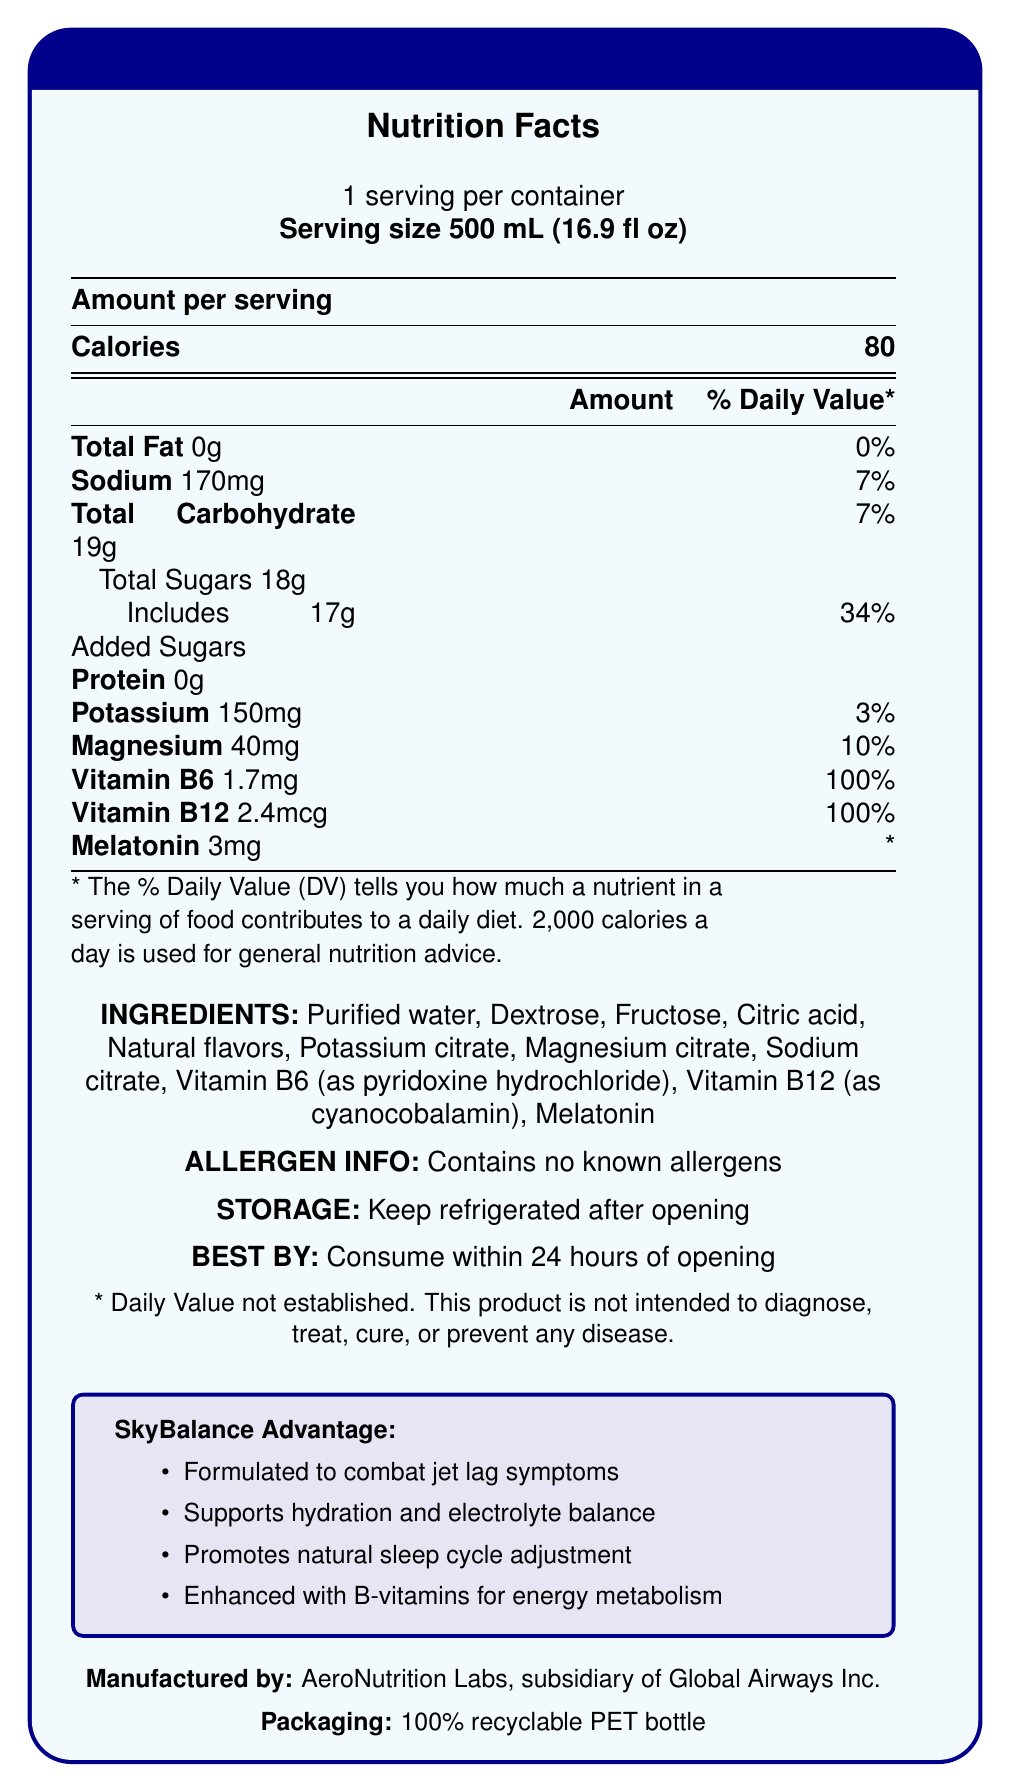what is the serving size of the SkyBalance Jet Lag Recovery Drink? The document states that the serving size is 500 mL (16.9 fl oz).
Answer: 500 mL (16.9 fl oz) how many calories are in one serving of the drink? The document lists the calorie content as 80 calories per serving.
Answer: 80 calories what is the total amount of carbohydrates in the drink? The document indicates that the total amount of carbohydrates is 19g per serving.
Answer: 19g what is the percentage of the daily value for added sugars in one serving? The document shows that 17g of added sugars contribute to 34% of the daily value.
Answer: 34% how much melatonin does the drink contain per serving? The document specifies that each serving contains 3mg of melatonin.
Answer: 3mg what vitamins are present in the SkyBalance Jet Lag Recovery Drink? The document lists Vitamin B6 (1.7mg, 100% DV) and Vitamin B12 (2.4mcg, 100% DV).
Answer: Vitamin B6 and Vitamin B12 which of the following is not an ingredient in the drink? A. Purified water B. Sodium citrate C. Aspartame D. Citric acid The document lists all the ingredients, and Aspartame is not one of them.
Answer: C what is the percentage daily value of magnesium in a serving? The document indicates that a serving contains 40mg of magnesium, which is 10% of the daily value.
Answer: 10% does the drink contain any known allergens? The document states that the drink contains no known allergens.
Answer: No how should the drink be stored after opening? The document advises to keep the drink refrigerated after opening.
Answer: Keep refrigerated what is the best by time frame for consumption after opening the drink? The document mentions that the drink should be consumed within 24 hours of opening.
Answer: Consume within 24 hours what are the main benefits of the SkyBalance Jet Lag Recovery Drink according to the document? The document highlights these benefits under "SkyBalance Advantage".
Answer: Combat jet lag symptoms, support hydration and electrolyte balance, promote natural sleep cycle adjustment, enhance energy metabolism with B-vitamins who manufactures the SkyBalance Jet Lag Recovery Drink? The document specifies that the drink is manufactured by AeroNutrition Labs, a subsidiary of Global Airways Inc.
Answer: AeroNutrition Labs, subsidiary of Global Airways Inc. what is a unique feature of the SkyBalance Jet Lag Recovery Drink compared to standard hydration drinks? The document mentions this in the section labeled "competitive edge."
Answer: Incorporates melatonin and specific B-vitamins tailored for air travel recovery describes the packaging of the drink The document indicates that the drink comes in a 100% recyclable PET bottle.
Answer: 100% recyclable PET bottle can the exact source of the melatonin in the drink be determined from the document? The document only lists melatonin as an ingredient but does not specify its source.
Answer: Not enough information summarize the main idea of the document The document provides detailed nutritional information, ingredients, and the unique benefits of the SkyBalance Jet Lag Recovery Drink.
Answer: The SkyBalance Jet Lag Recovery Drink is specially formulated to combat jet lag symptoms, support hydration and electrolyte balance, and promote natural sleep cycle adjustment. It contains essential B-vitamins, magnesium, potassium, and melatonin to aid travel recovery. The drink has a serving size of 500 mL, contributes 80 calories per serving, and contains no known allergens. It is manufactured by AeroNutrition Labs and comes in a 100% recyclable PET bottle. what should consumers note about the storage and expiration of the drink? The document clearly states that the drink should be kept refrigerated after opening and is best consumed within 24 hours.
Answer: Keep refrigerated after opening and consume within 24 hours 